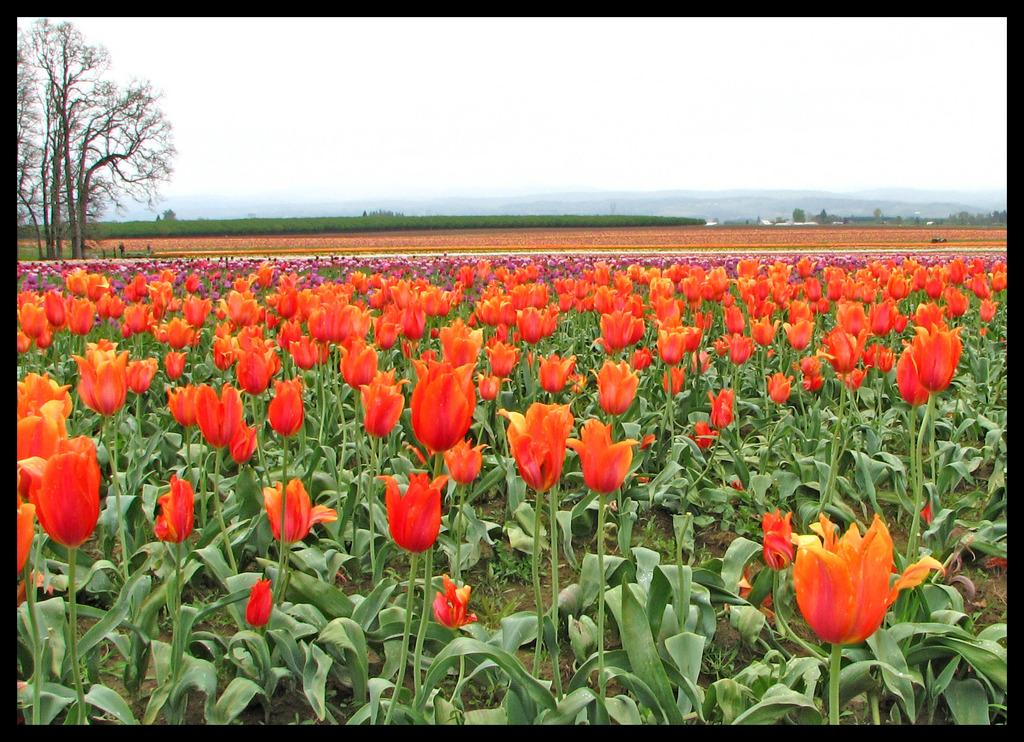What type of flowers can be seen in the image? There are tulip flowers in the image. What can be seen in the distance behind the flowers? There are mountains visible in the background of the image. What other natural elements are present in the background? There are trees and plants in the background of the image. What type of club does the daughter use to write with in the image? There is no club or daughter present in the image; it features tulip flowers and a background with mountains, trees, and plants. 